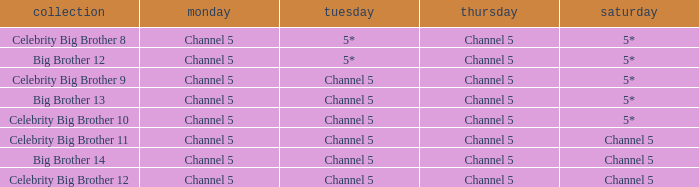Which Thursday does big brother 13 air? Channel 5. 